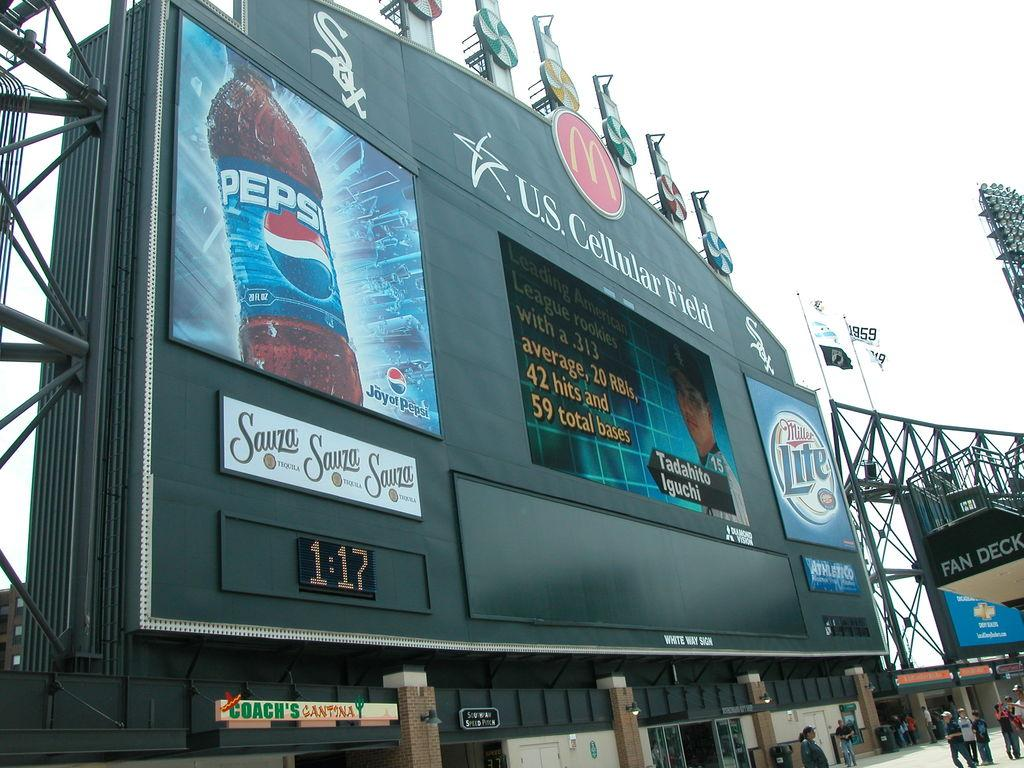<image>
Create a compact narrative representing the image presented. The jumbo screen at the U.S. Cellular Field. 